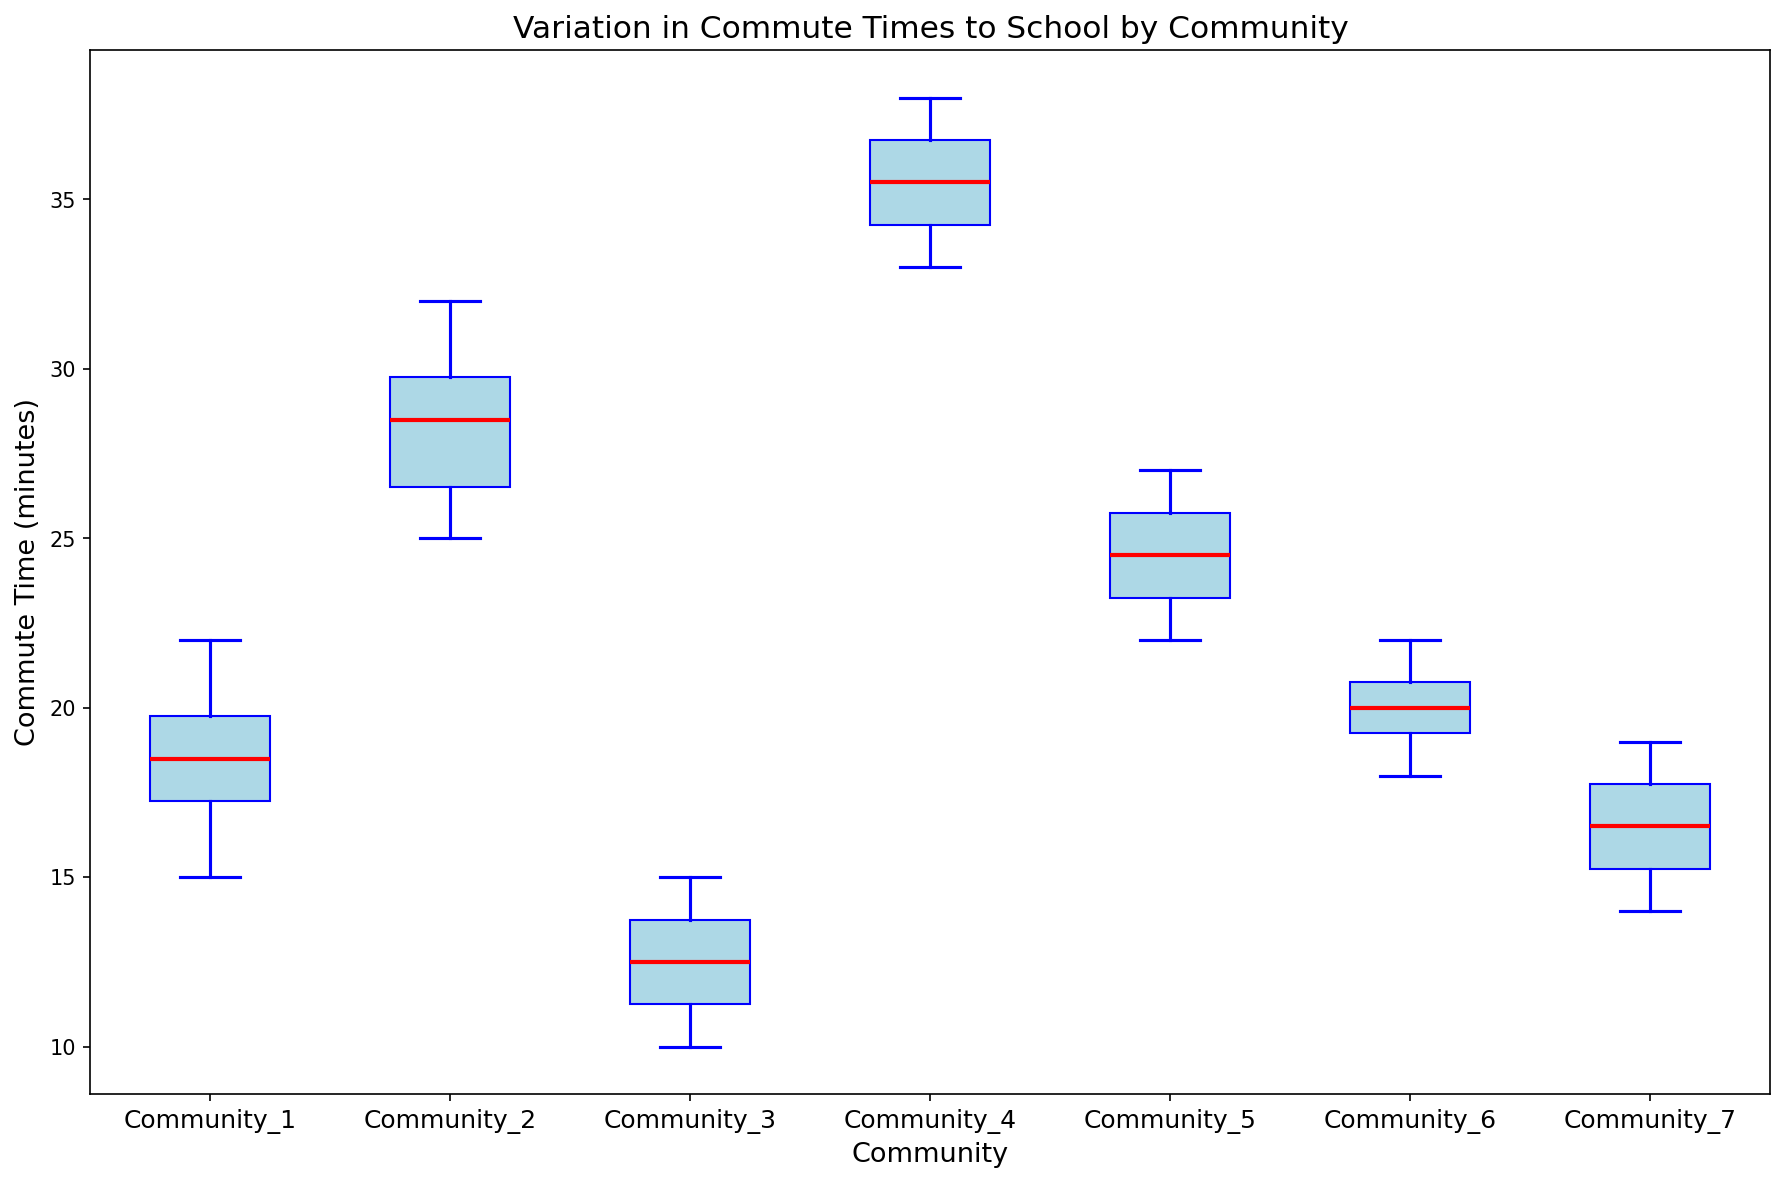What is the median commute time for Community 2? The median of a data set is the middle value when the values are arranged in ascending order. For Community 2, the commute times are {25, 26, 28, 29, 30, 32}. The median is the average of the two middle numbers (28 and 29), (28+29)/2 = 28.5.
Answer: 28.5 Which community has the highest median commute time? The median value for each community can be observed from the plots. Community 4 clearly has the highest median commute time as its median line is positioned highest on the y-axis.
Answer: Community 4 What is the range of commute times in Community 1? The range is the difference between the maximum and minimum values. For Community 1, the maximum is 22 and the minimum is 15. So, the range is 22 - 15 = 7.
Answer: 7 Compare the interquartile ranges (IQR) of Community 3 and Community 7. Which one has a larger IQR? The IQR is the difference between the third quartile (Q3) and the first quartile (Q1). Community 3's IQR can be found by identifying Q3 and Q1 on the box and doing the same for Community 7. Without exact numerical values but visually, Community 3's IQR (14 - 11) seems smaller than Community 7's IQR (18 - 15).
Answer: Community 7 Which communities have outliers in their commute times? Outliers are typically shown as points outside the whiskers of a box plot. By observing the plots, Community 1 and Community 2 show points outside the whiskers, indicating outliers.
Answer: Community 1, Community 2 What is the difference between the median commute times of Community 5 and Community 6? The median commute time for Community 5 can be observed directly from the plot at around 24.5, and for Community 6 it is around 20. So the difference is approximately 24.5 - 20 = 4.5.
Answer: 4.5 Which community has the smallest variation in commute times? The community with the smallest box and whiskers range represents the smallest variation. By observing the plots, Community 3 has the smallest variation as it has the shortest box and whiskers.
Answer: Community 3 